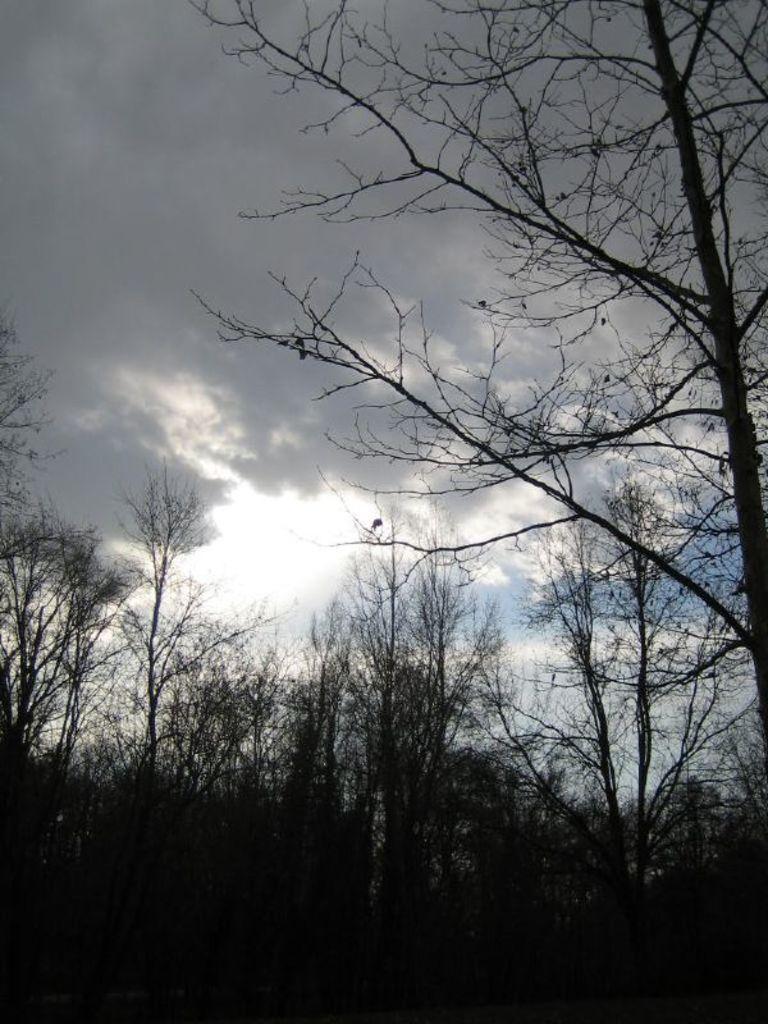Please provide a concise description of this image. In the picture I can see trees. In the background I can see the sky. 